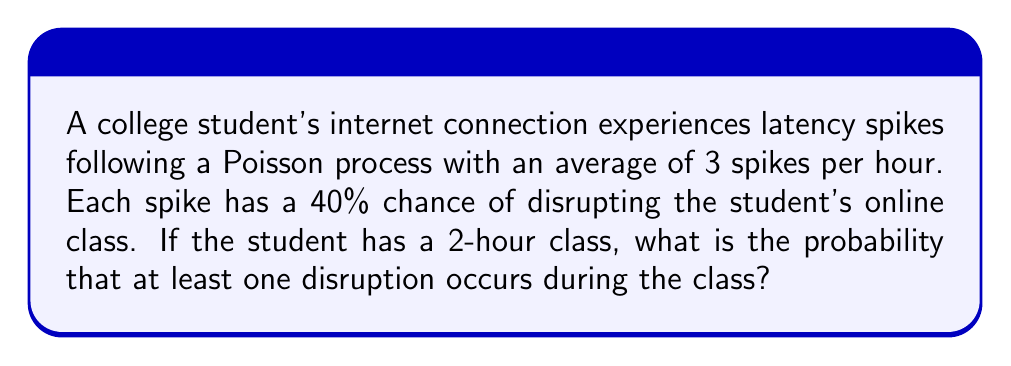Can you solve this math problem? Let's approach this step-by-step:

1) First, we need to determine the rate parameter $\lambda$ for the 2-hour period:
   $\lambda = 3 \text{ spikes/hour} \times 2 \text{ hours} = 6 \text{ spikes}$

2) Each spike has a 40% chance of causing a disruption. We can model this as a thinned Poisson process. The new rate parameter for disruptive spikes is:
   $\lambda_{disruptive} = 6 \times 0.4 = 2.4 \text{ disruptive spikes}$

3) We want to find the probability of at least one disruption. This is equivalent to 1 minus the probability of no disruptions:

   $P(\text{at least one disruption}) = 1 - P(\text{no disruptions})$

4) The number of disruptions follows a Poisson distribution with $\lambda = 2.4$. The probability of no disruptions is:

   $P(\text{no disruptions}) = P(X = 0) = \frac{e^{-\lambda}\lambda^k}{k!} = \frac{e^{-2.4}(2.4)^0}{0!} = e^{-2.4}$

5) Therefore, the probability of at least one disruption is:

   $P(\text{at least one disruption}) = 1 - e^{-2.4}$

6) Calculating this:
   $1 - e^{-2.4} \approx 0.9093$
Answer: $1 - e^{-2.4} \approx 0.9093$ 